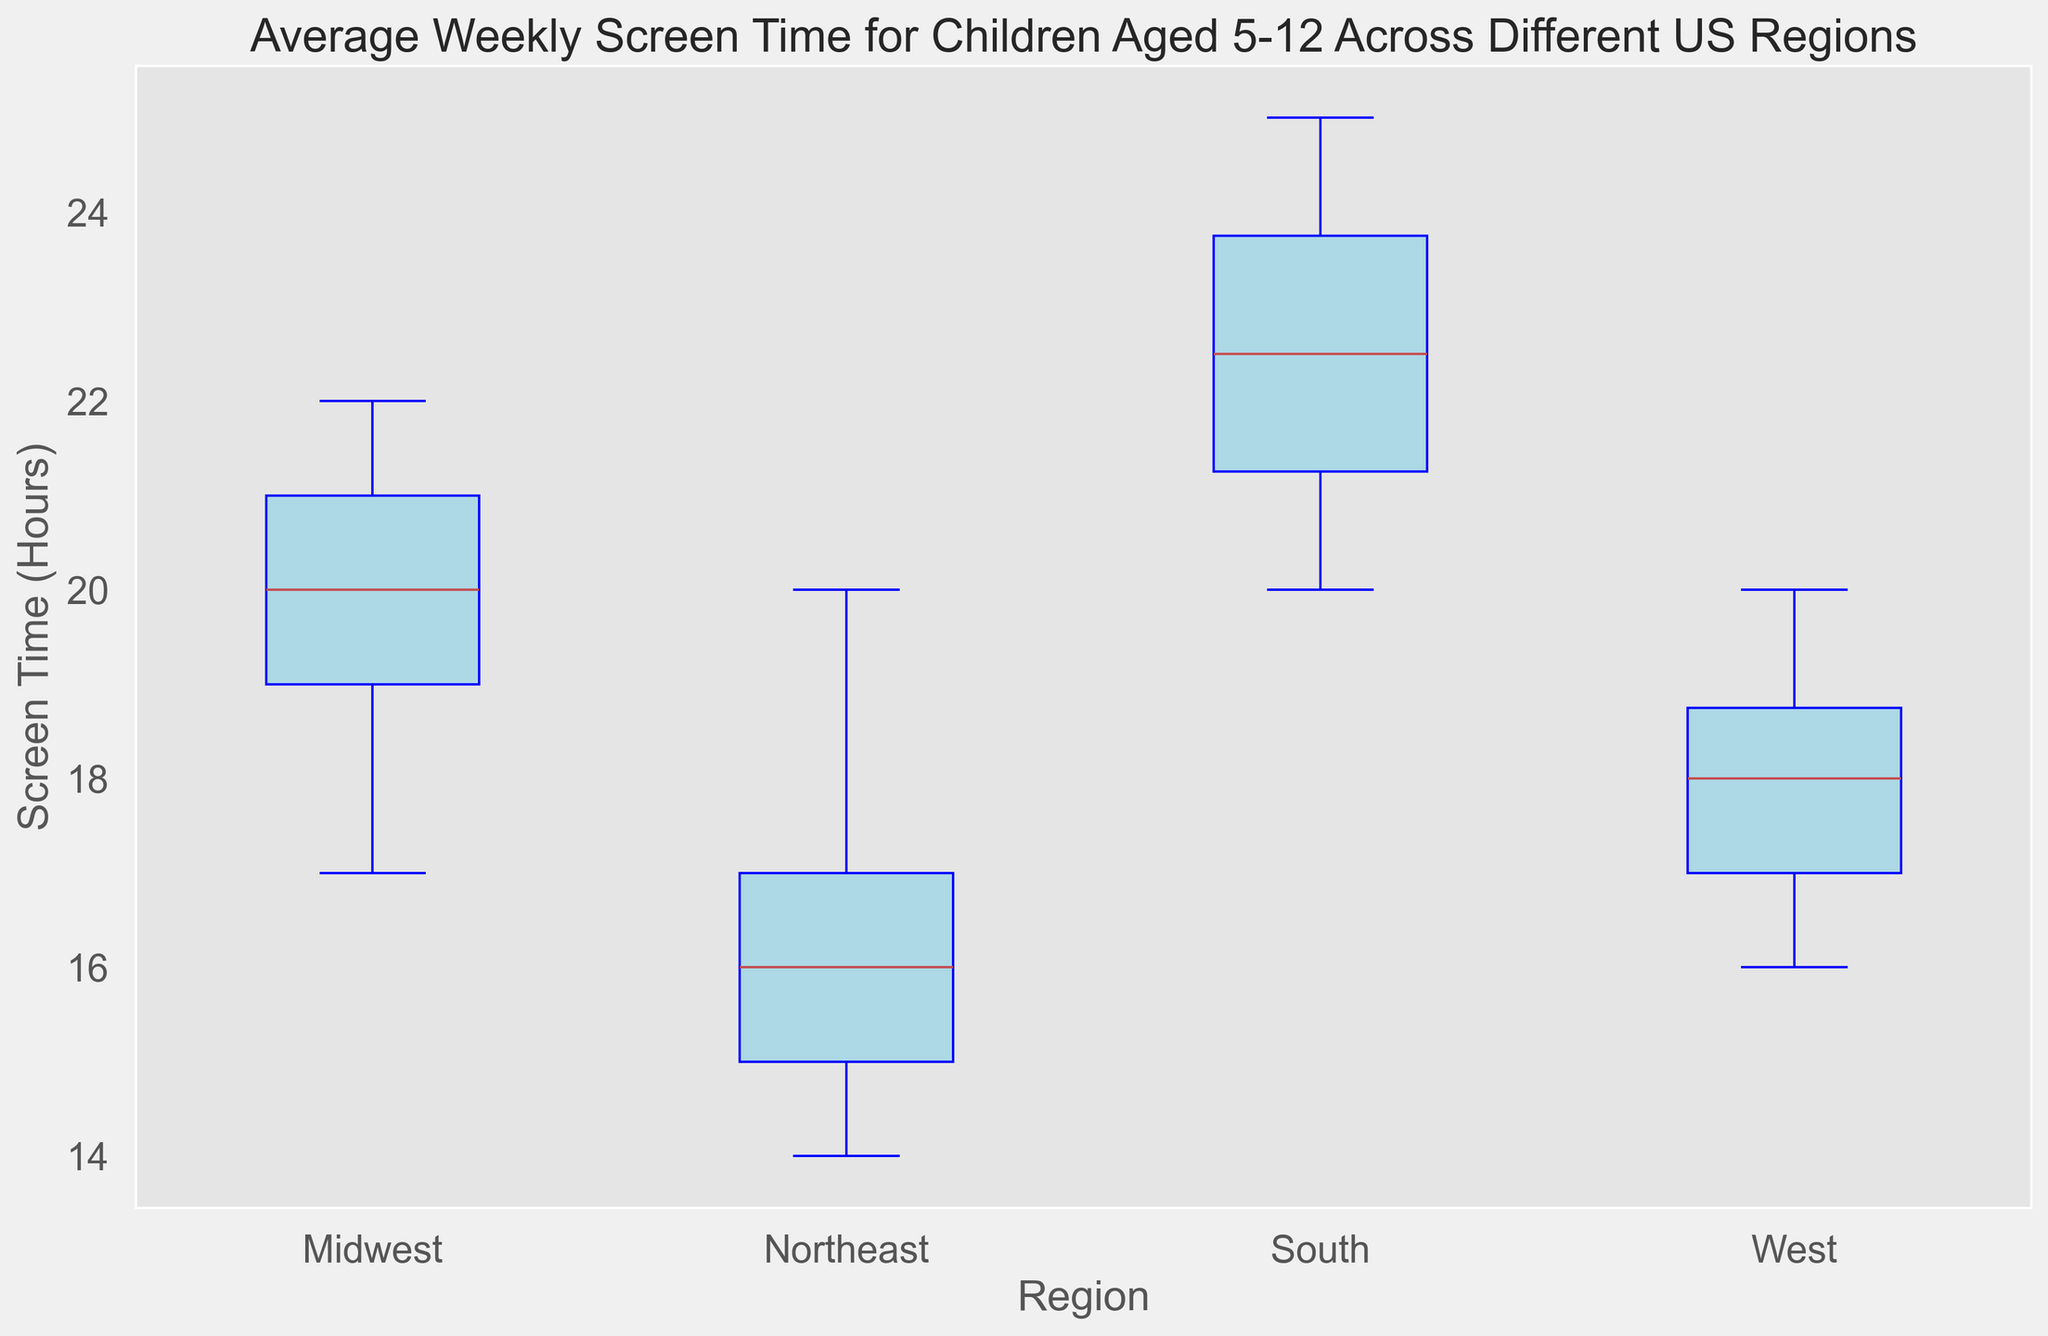What is the median screen time for children in the Northeast? To find the median screen time for the Northeast, locate the middle value in the box plot for that region. The median is represented by the line inside the box.
Answer: 16 hours Which region has the highest median screen time? By looking at the center line of the boxes in the box plot, identify the region whose median line is highest.
Answer: South Which region has the lowest variability in screen time? Variability is represented by the length of the box and the whiskers. Look for the region with the shortest overall length in the box plot.
Answer: West How does the interquartile range (IQR) for the South compare to the West? The IQR is the range between the first quartile (bottom of the box) and third quartile (top of the box). Compare the height of the boxes for the South and the West regions.
Answer: South has a larger IQR than West Which region shows outliers, and what color are they represented by? Outliers are represented by distinct dots outside the whiskers in the box plot. Note the region(s) showing these dots and their color.
Answer: Midwest and South, red Among the regions, which one has the most consistent weekly screen time? Consistency is indicated by the smallest spread between the minimum and maximum values. Identify the region with the smallest overall vertical range including whiskers.
Answer: West Compare the median screen time between the Midwest and the Northeast regions. Which is higher? Locate the median lines for both the Midwest and Northeast in the box plot and compare their positions.
Answer: Midwest If you combine the variability of the Northeast and the South, how does it compare to the West? Sum up the lengths of the boxes (representing the IQR) and whiskers for both Northeast and South, and compare it to the length of the box and whiskers of the West.
Answer: Combined variability of Northeast and South is higher Which region displays the highest screen time range? The range is the length from the minimum whisker to the maximum whisker. Identify the region with the greatest vertical extent.
Answer: South Are there any regions with an equal median screen time? If so, which ones? By examining the median lines of all regions, check if any two regions have medians at the same level.
Answer: Northeast and West, both have a median of 16 hours 